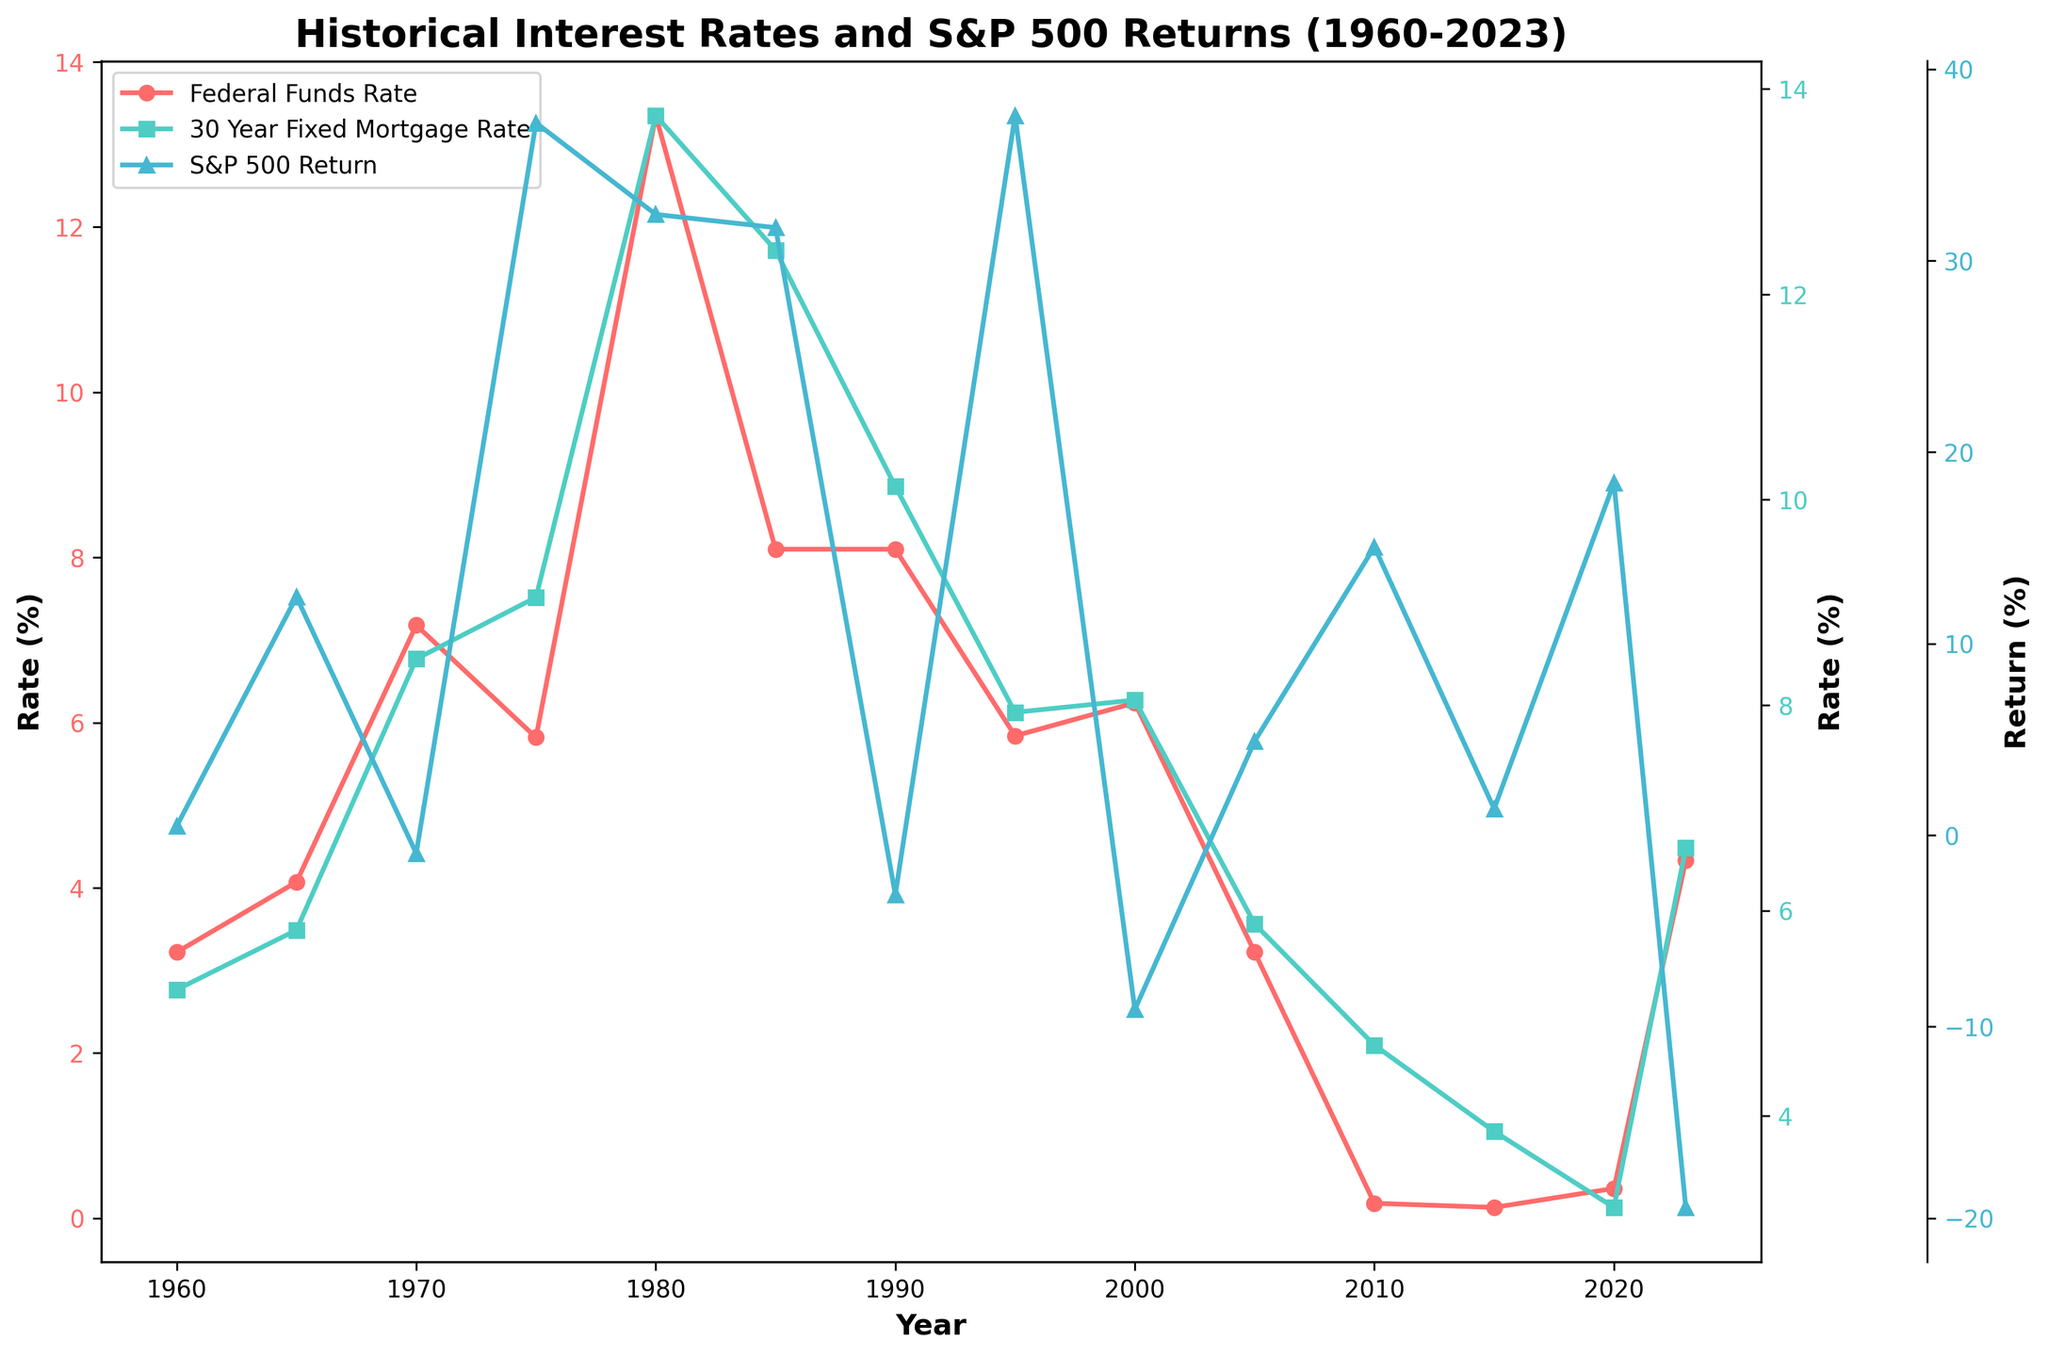What was the Federal Funds Rate in 1980? Locate the red line (Federal Funds Rate) on the chart and find the value corresponding to the year 1980. The value is approximately 13.35%.
Answer: 13.35% During which year did the S&P 500 Return peak according to the chart? Look for the highest point on the blue line (S&P 500 Return). The year that corresponds to this point is 1995, with a return of around 37.58%.
Answer: 1995 Compare the Federal Funds Rate and 30 Year Fixed Mortgage Rate in 2023. Which one was higher? Look at the red line (Federal Funds Rate) and the green line (30 Year Fixed Mortgage Rate) for the year 2023. The Federal Funds Rate is around 4.33% and the Mortgage Rate is approximately 6.61%.
Answer: 30 Year Fixed Mortgage Rate What is the difference between the S&P 500 Return in 1970 and 1975? Identify the values of the blue line (S&P 500 Return) in 1970 (-0.95%) and in 1975 (37.20%). Subtract the 1970 value from the 1975 value: 37.20% - (-0.95%) = 38.15%.
Answer: 38.15% How did the Federal Funds Rate change from 1960 to 1980? Observe the red line (Federal Funds Rate) from the year 1960 to 1980. The rate increases from around 3.22% in 1960 to about 13.35% in 1980.
Answer: Increased Which year experienced the steepest increase in the Federal Funds Rate? Look for the year with the steepest upward slope on the red line (Federal Funds Rate). The steepest increase occurs between 1970 and 1980, where it jumps notably.
Answer: Between 1970 and 1980 In what year did the S&P 500 experience a negative return? Look for the points on the blue line (S&P 500 Return) that fall below the x-axis (0%). The years where this happens are 1970, 1990, 2000, and 2023.
Answer: 1970, 1990, 2000, 2023 What is the combined value of the Federal Funds Rate and the 30 Year Fixed Mortgage Rate in 2015? Find the Federal Funds Rate and the 30 Year Fixed Mortgage Rate for 2015. Federal Funds Rate is about 0.13% and the Mortgage Rate is approximately 3.85%. Adding these together, 0.13% + 3.85% = 3.98%.
Answer: 3.98% Did the Federal Funds Rate or 30 Year Fixed Mortgage Rate change more between 2010 and 2020? Compare the change in values of the red line (Federal Funds Rate) and the green line (30 Year Fixed Mortgage Rate) from 2010 to 2020. Federal Funds Rate changes from 0.18% to 0.36% (0.36% - 0.18% = 0.18%). Mortgage Rate changes from 4.69% to 3.11% (4.69% - 3.11% = 1.58%).
Answer: 30 Year Fixed Mortgage Rate What was the trend of inflation rates from 2010 to 2023? Since inflation rates are not directly shown on the chart, look at the general timeframe for rising or falling trends using other information points (possibly referencing the Bond Yield, often correlated with inflation). Examining inflation as part of a multi-variable consideration may show mixed trends.
Answer: Mixed trends 